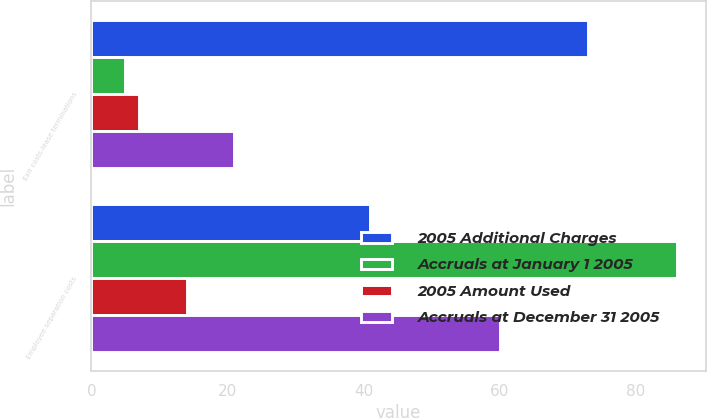<chart> <loc_0><loc_0><loc_500><loc_500><stacked_bar_chart><ecel><fcel>Exit costs-lease terminations<fcel>Employee separation costs<nl><fcel>2005 Additional Charges<fcel>73<fcel>41<nl><fcel>Accruals at January 1 2005<fcel>5<fcel>86<nl><fcel>2005 Amount Used<fcel>7<fcel>14<nl><fcel>Accruals at December 31 2005<fcel>21<fcel>60<nl></chart> 